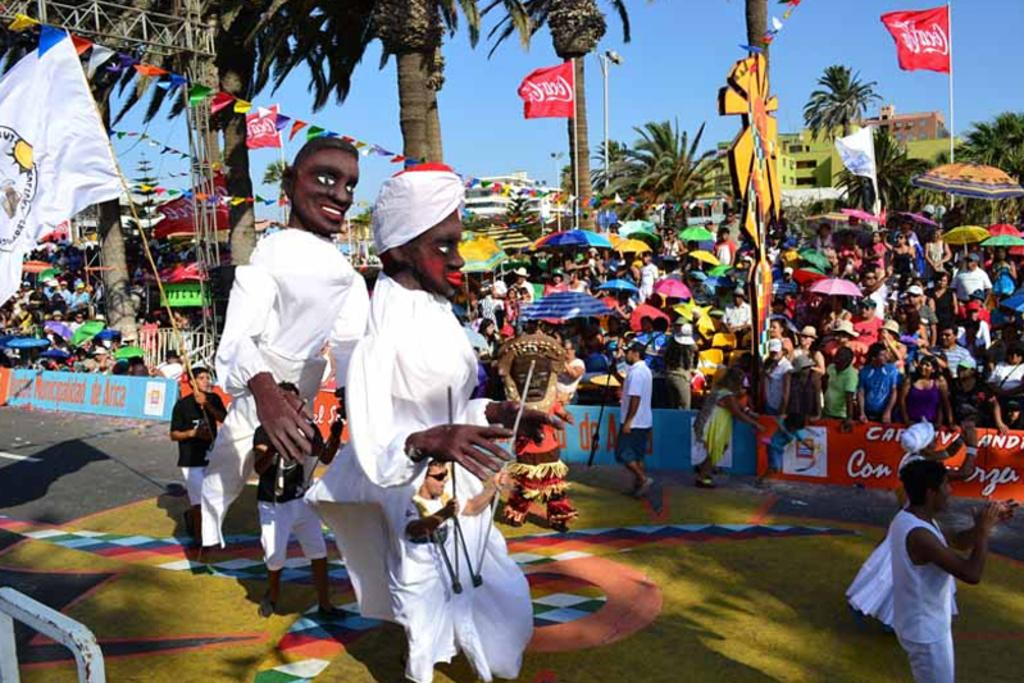<image>
Describe the image concisely. A parade is happening with Coca Cola ads 